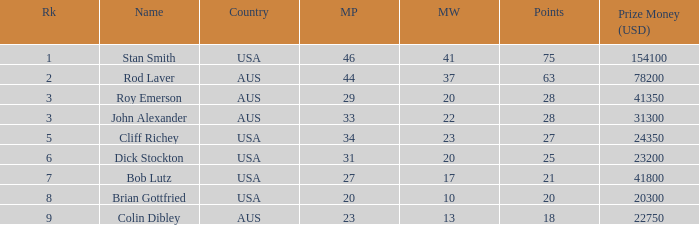How many matches did colin dibley win 13.0. 